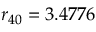<formula> <loc_0><loc_0><loc_500><loc_500>r _ { 4 0 } = 3 . 4 7 7 6</formula> 